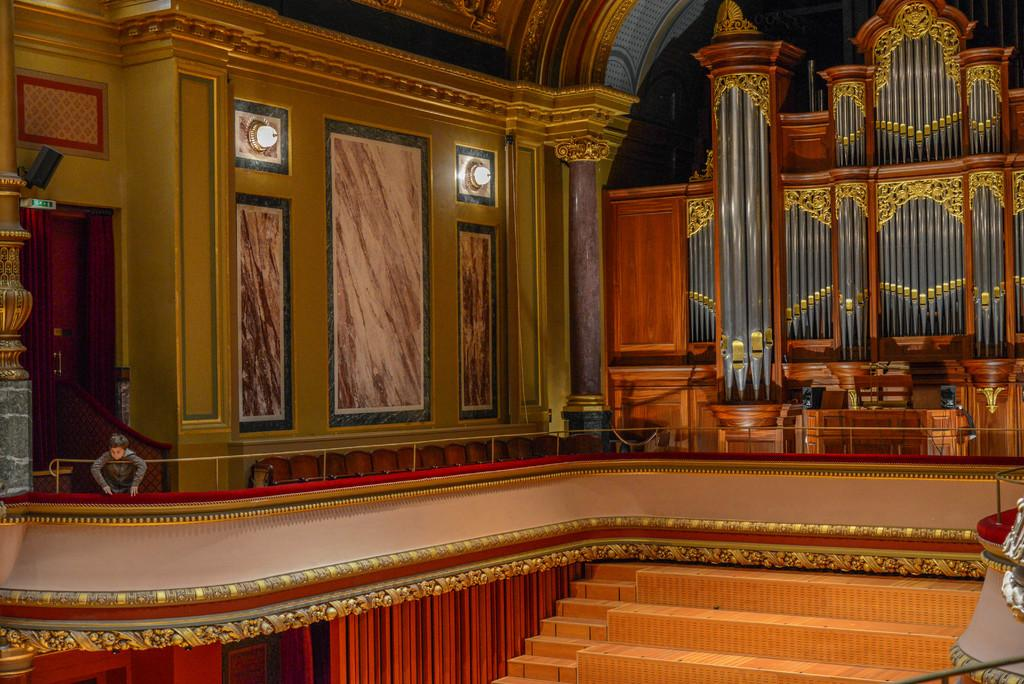What type of space is shown in the image? The image is an inside view of a room. What are some of the features of the room? There are walls, lights, pillars, a speaker, a board, a door, and stairs in the room. Is there any furniture or objects in the room? The presence of a person in the room suggests that there might be furniture or objects, but the facts provided do not specify any. What is the person in the room doing? The facts provided do not specify what the person is doing. Can you see the person's wings in the image? There are no wings visible in the image. Is the person kicking a ball in the room? The facts provided do not mention a ball or any activity involving kicking. 